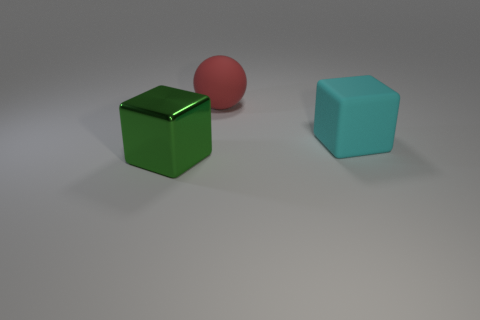Add 2 tiny cyan metallic cylinders. How many objects exist? 5 Subtract all blocks. How many objects are left? 1 Subtract all blue cubes. Subtract all purple cylinders. How many cubes are left? 2 Subtract all brown cylinders. How many purple spheres are left? 0 Subtract all large green metallic things. Subtract all small brown rubber cubes. How many objects are left? 2 Add 1 cubes. How many cubes are left? 3 Add 3 large brown blocks. How many large brown blocks exist? 3 Subtract 0 green balls. How many objects are left? 3 